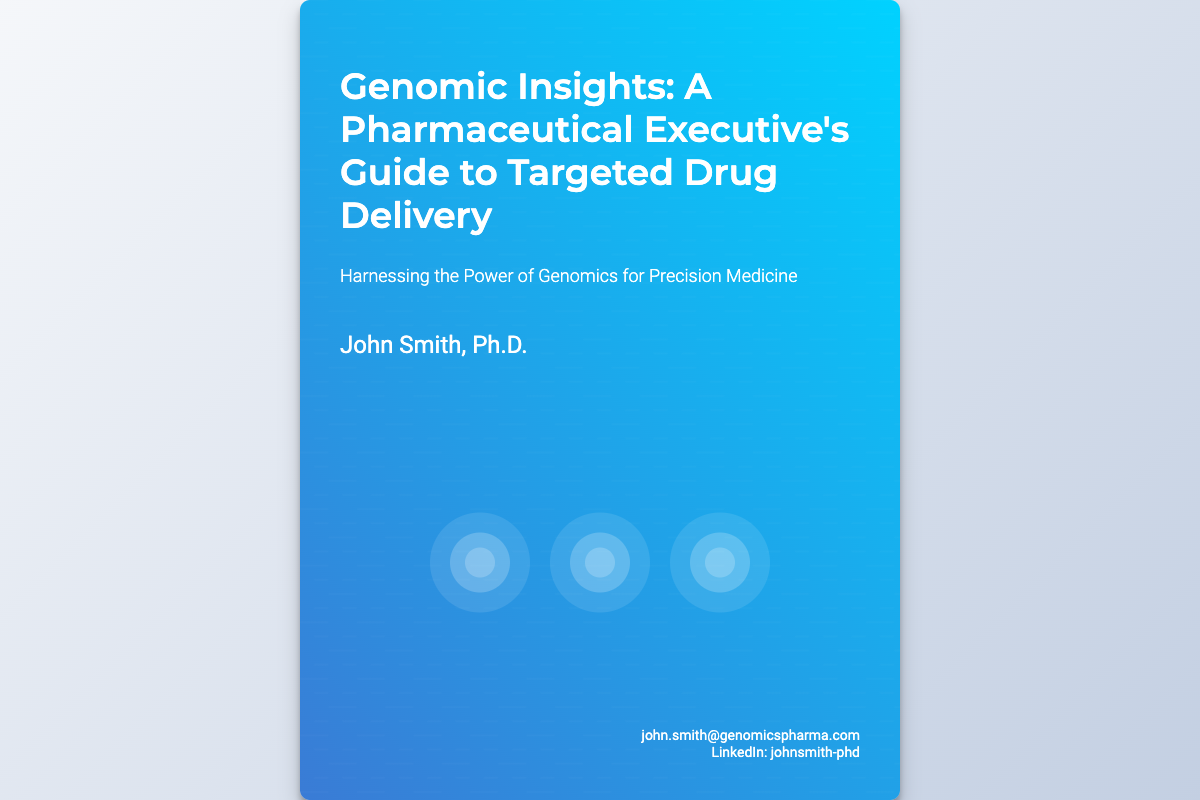what is the title of the book? The title of the book is prominently displayed in the header of the cover.
Answer: Genomic Insights: A Pharmaceutical Executive's Guide to Targeted Drug Delivery who is the author of the book? The author's name is mentioned near the bottom of the cover.
Answer: John Smith, Ph.D what is the tagline of the book? The tagline that summarizes the book's focus and theme is located below the title.
Answer: Harnessing the Power of Genomics for Precision Medicine how many molecules are depicted on the cover? There are three molecular representations shown in the content area of the cover.
Answer: 3 what effect is used in the background of the cover? The background features a gradient effect that transitions between two colors, creating a modern look.
Answer: Linear gradient what style of font is used for the title? The font chosen for the title gives it a distinct appearance, important for visual prominence.
Answer: Montserrat what color scheme is primarily used in the design? The design utilizes a combination of blue and turquoise, creating a fresh and modern aesthetic.
Answer: Blue and turquoise what is the purpose of this book? The purpose is to guide pharmaceutical executives on utilizing genomics in drug development.
Answer: Guide to targeted drug delivery what contact information is provided on the cover? The cover includes an email address and a LinkedIn profile for further contact.
Answer: john.smith@genomicspharma.com 